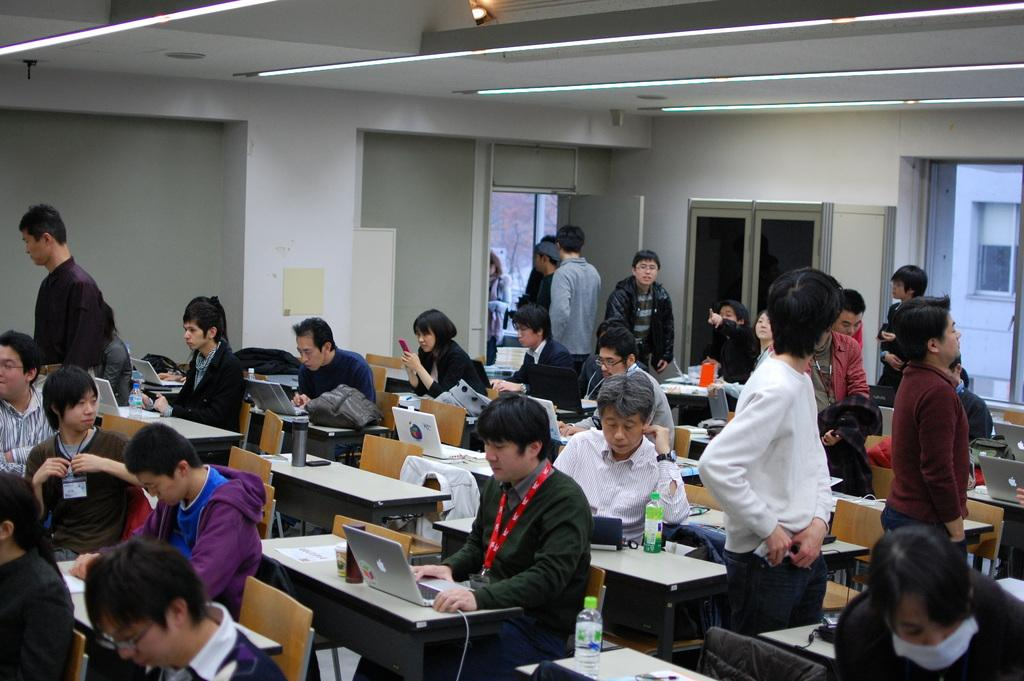How many people are in the image? There are people in the image, but the exact number is not specified. What type of furniture is present in the image? There are chairs and tables in the image. What architectural features can be seen in the image? There are windows and a wall in the image. What type of lighting is present in the image? There are lights in the image. What objects are on the tables? There are bottles and laptops on the tables. Are any people sitting on the chairs? Some people are sitting on the chairs. Can you see a gun on any of the tables in the image? No, there is no gun present on any of the tables in the image. 